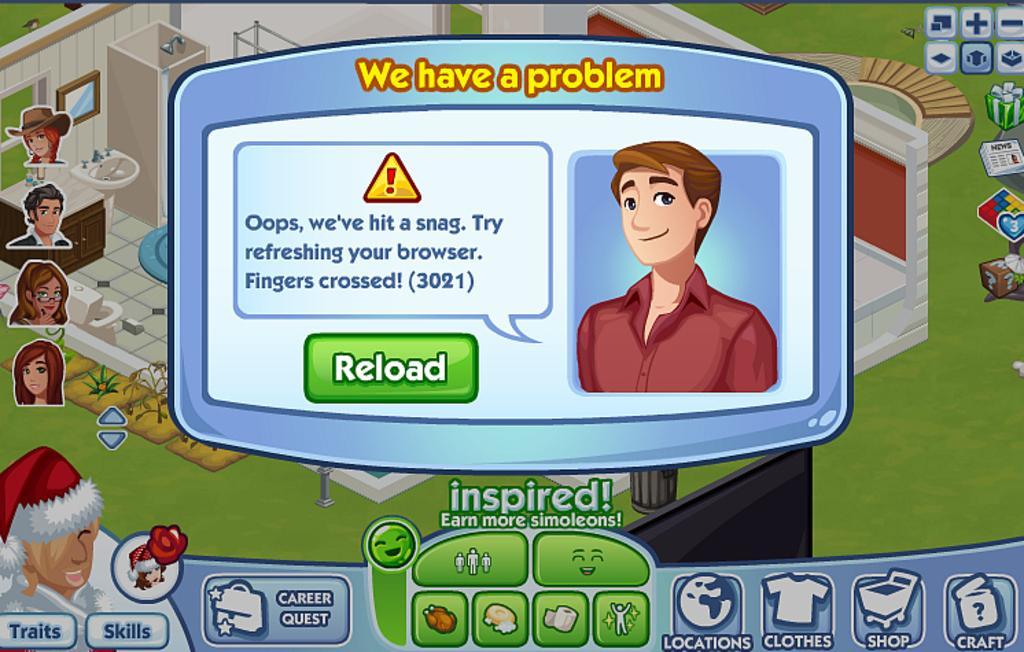How would you summarize this image in a sentence or two? In this images we can see cartoon persons, notification box, grass on the ground, shower, sink, mirror on the wall and on the right side there are objects. At the bottom we can see categories. 